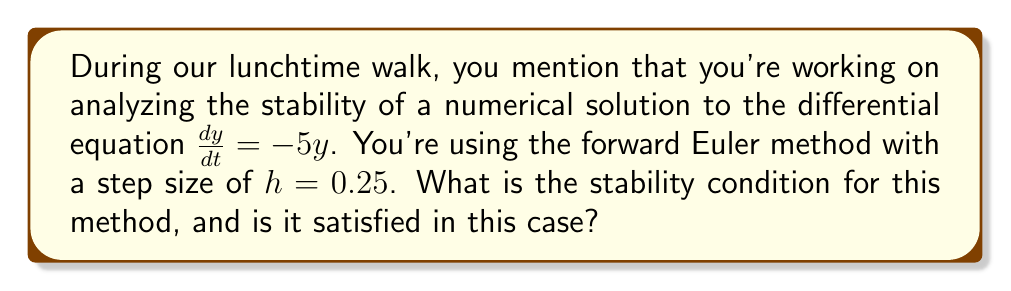Show me your answer to this math problem. Let's approach this step-by-step:

1) The forward Euler method for solving $\frac{dy}{dt} = f(t,y)$ is given by:

   $$y_{n+1} = y_n + hf(t_n, y_n)$$

2) In this case, $f(t,y) = -5y$, so the method becomes:

   $$y_{n+1} = y_n + h(-5y_n) = (1-5h)y_n$$

3) For stability, we need $|1-5h| \leq 1$

4) This inequality can be broken down into two conditions:
   
   $$-1 \leq 1-5h \leq 1$$

5) Solving these inequalities:

   $$-2 \leq -5h \leq 0$$
   $$0 \leq 5h \leq 2$$
   $$0 \leq h \leq 0.4$$

6) Therefore, the stability condition is $0 \leq h \leq 0.4$

7) In this problem, $h = 0.25$

8) Since $0 \leq 0.25 \leq 0.4$, the stability condition is satisfied.
Answer: Stability condition: $0 \leq h \leq 0.4$; Satisfied for $h = 0.25$ 